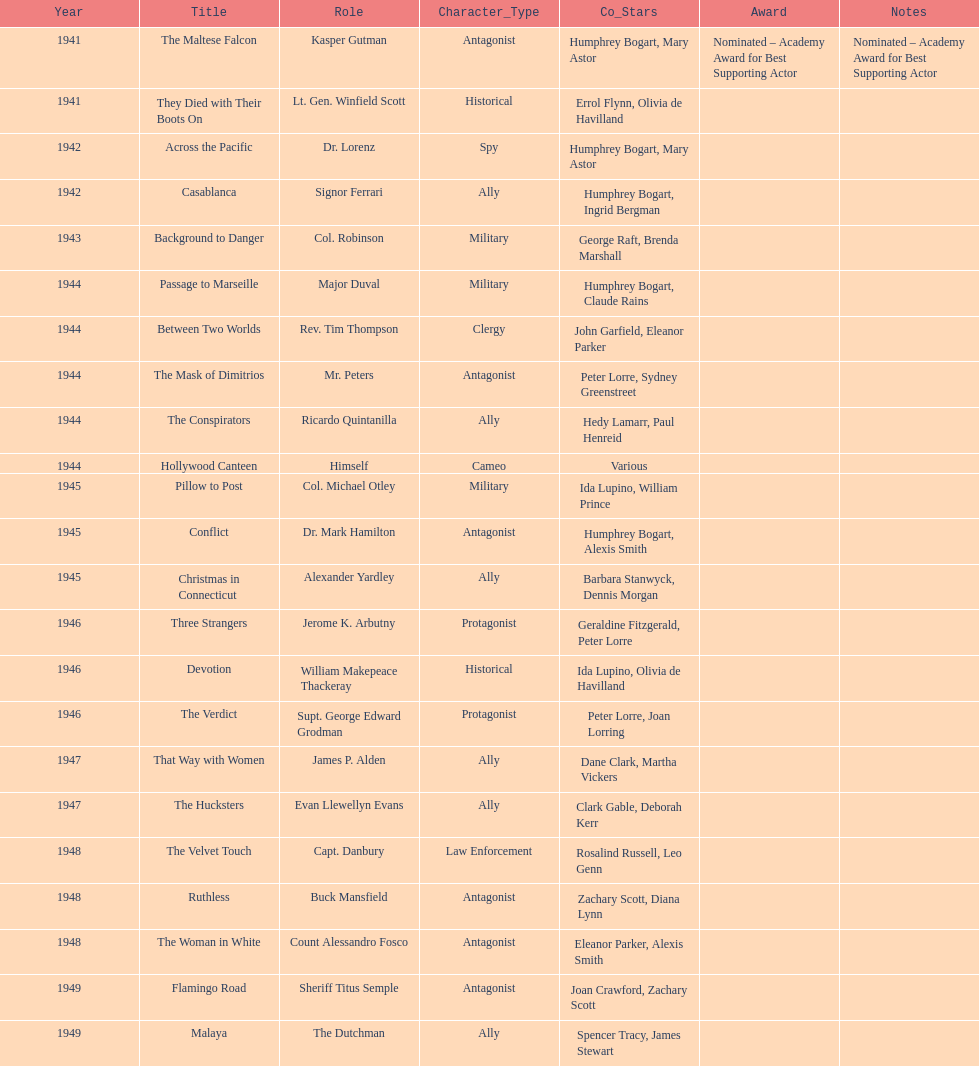How many movies has he been from 1941-1949. 23. 